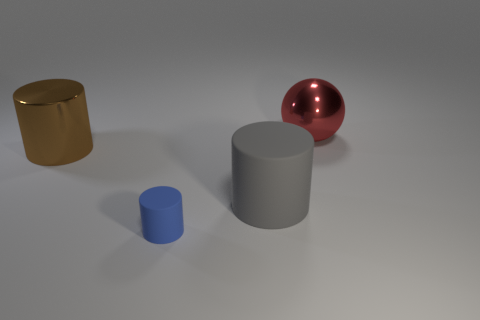Add 3 big brown metal cubes. How many objects exist? 7 Subtract all cylinders. How many objects are left? 1 Subtract all small brown metal objects. Subtract all red metallic spheres. How many objects are left? 3 Add 1 blue rubber things. How many blue rubber things are left? 2 Add 2 large gray matte objects. How many large gray matte objects exist? 3 Subtract 0 brown cubes. How many objects are left? 4 